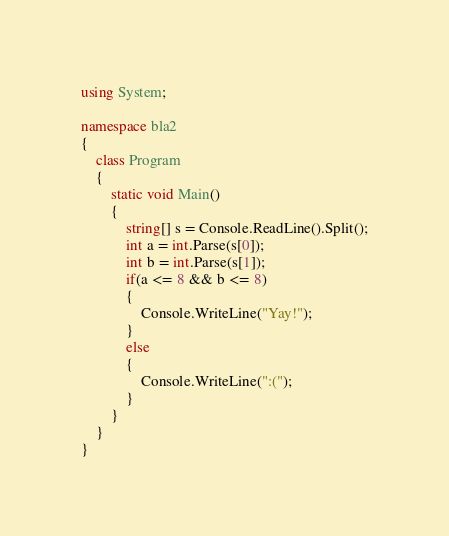<code> <loc_0><loc_0><loc_500><loc_500><_C#_>using System;

namespace bla2
{
    class Program
    {
        static void Main()
        {
            string[] s = Console.ReadLine().Split();
            int a = int.Parse(s[0]);
            int b = int.Parse(s[1]);
            if(a <= 8 && b <= 8)
            {
                Console.WriteLine("Yay!");
            }
            else
            {
                Console.WriteLine(":(");
            }
        }
    }
}
</code> 